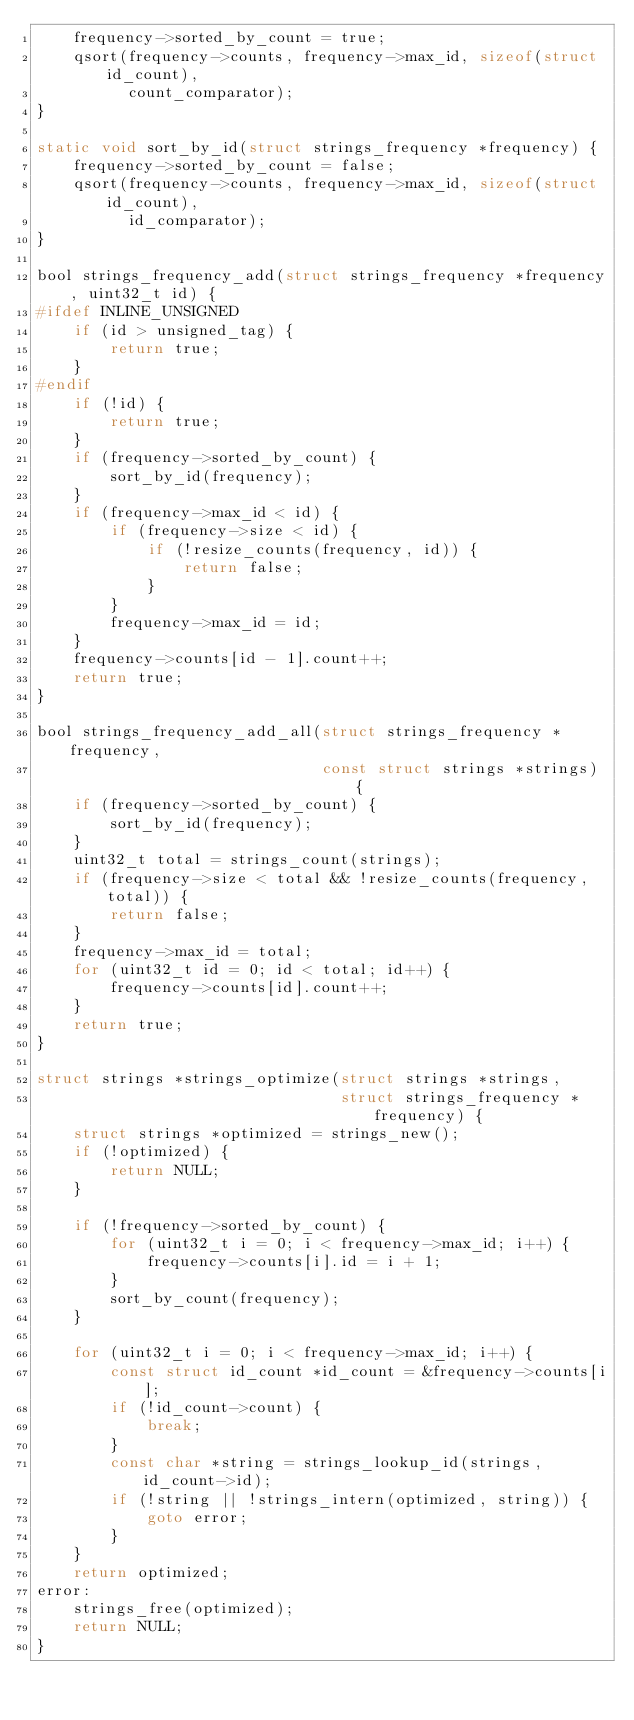Convert code to text. <code><loc_0><loc_0><loc_500><loc_500><_C_>    frequency->sorted_by_count = true;
    qsort(frequency->counts, frequency->max_id, sizeof(struct id_count),
          count_comparator);
}

static void sort_by_id(struct strings_frequency *frequency) {
    frequency->sorted_by_count = false;
    qsort(frequency->counts, frequency->max_id, sizeof(struct id_count),
          id_comparator);
}

bool strings_frequency_add(struct strings_frequency *frequency, uint32_t id) {
#ifdef INLINE_UNSIGNED
    if (id > unsigned_tag) {
        return true;
    }
#endif
    if (!id) {
        return true;
    }
    if (frequency->sorted_by_count) {
        sort_by_id(frequency);
    }
    if (frequency->max_id < id) {
        if (frequency->size < id) {
            if (!resize_counts(frequency, id)) {
                return false;
            }
        }
        frequency->max_id = id;
    }
    frequency->counts[id - 1].count++;
    return true;
}

bool strings_frequency_add_all(struct strings_frequency *frequency,
                               const struct strings *strings) {
    if (frequency->sorted_by_count) {
        sort_by_id(frequency);
    }
    uint32_t total = strings_count(strings);
    if (frequency->size < total && !resize_counts(frequency, total)) {
        return false;
    }
    frequency->max_id = total;
    for (uint32_t id = 0; id < total; id++) {
        frequency->counts[id].count++;
    }
    return true;
}

struct strings *strings_optimize(struct strings *strings,
                                 struct strings_frequency *frequency) {
    struct strings *optimized = strings_new();
    if (!optimized) {
        return NULL;
    }

    if (!frequency->sorted_by_count) {
        for (uint32_t i = 0; i < frequency->max_id; i++) {
            frequency->counts[i].id = i + 1;
        }
        sort_by_count(frequency);
    }

    for (uint32_t i = 0; i < frequency->max_id; i++) {
        const struct id_count *id_count = &frequency->counts[i];
        if (!id_count->count) {
            break;
        }
        const char *string = strings_lookup_id(strings, id_count->id);
        if (!string || !strings_intern(optimized, string)) {
            goto error;
        }
    }
    return optimized;
error:
    strings_free(optimized);
    return NULL;
}
</code> 